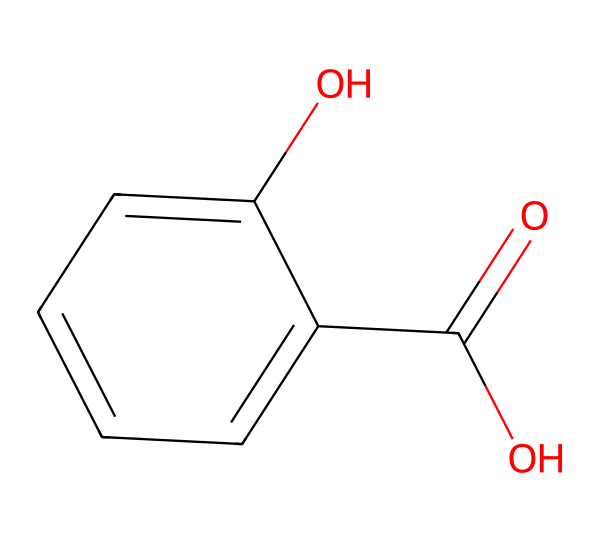What is the name of this compound? The structure corresponds to salicylic acid, which is known for its various uses, particularly in traditional herbal medicine. The presence of the carboxylic acid and hydroxyl groups indicates its designation as salicylic acid.
Answer: salicylic acid How many carbon atoms are in salicylic acid? By analyzing the structure, we can count six carbon atoms in the benzene ring and one in the carboxylic acid group, totaling seven carbon atoms in the entire molecule.
Answer: 7 What functional groups are present in salicylic acid? The structure includes a carboxylic acid group (–COOH) and a hydroxyl group (–OH), making these the two primary functional groups present in the compound.
Answer: carboxylic acid, hydroxyl Is salicylic acid an aromatic compound? The benzene ring in the structure indicates that salicylic acid has a delocalized electron system, which is a characteristic feature of aromatic compounds, thus confirming its classification.
Answer: yes What is the degree of unsaturation in salicylic acid? The presence of the benzene ring suggests a contribution to the degree of unsaturation. Each ringed carbon is counted, leading to a total of four degrees of unsaturation, which includes rings and double bonds.
Answer: 4 What is the pKa value of the carboxylic acid in salicylic acid? The pKa of carboxylic acid groups typically ranges from 4 to 5; for salicylic acid, the specific pKa value is around 2.98, indicating its acidity.
Answer: 2.98 